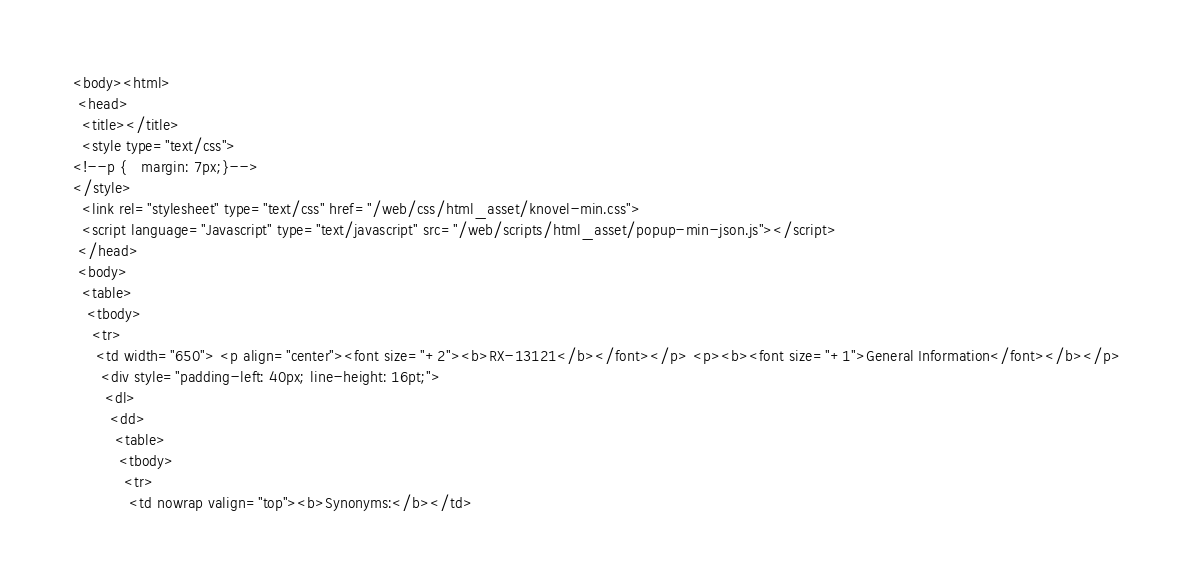Convert code to text. <code><loc_0><loc_0><loc_500><loc_500><_HTML_><body><html>
 <head> 
  <title></title> 
  <style type="text/css">
<!--p {   margin: 7px;}-->
</style> 
  <link rel="stylesheet" type="text/css" href="/web/css/html_asset/knovel-min.css">
  <script language="Javascript" type="text/javascript" src="/web/scripts/html_asset/popup-min-json.js"></script>
 </head> 
 <body> 
  <table> 
   <tbody>
    <tr> 
     <td width="650"> <p align="center"><font size="+2"><b>RX-13121</b></font></p> <p><b><font size="+1">General Information</font></b></p> 
      <div style="padding-left: 40px; line-height: 16pt;"> 
       <dl> 
        <dd> 
         <table> 
          <tbody>
           <tr> 
            <td nowrap valign="top"><b>Synonyms:</b></td> </code> 